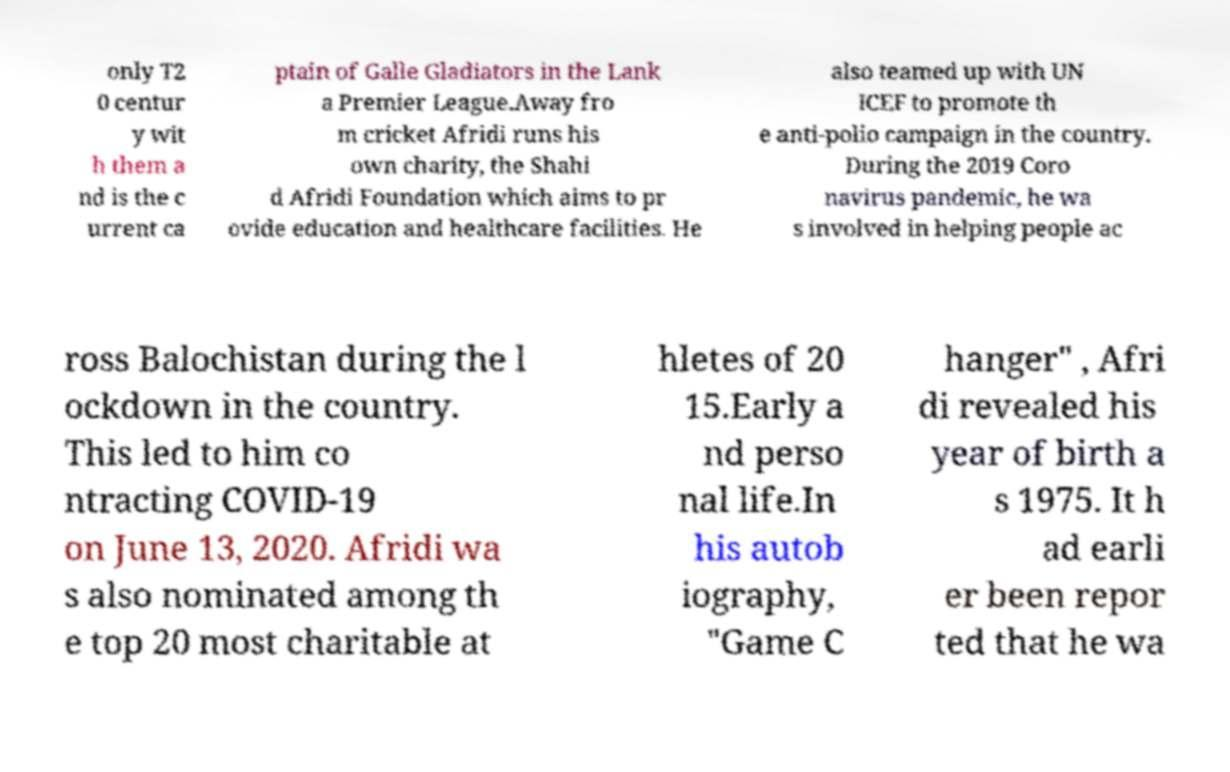Could you assist in decoding the text presented in this image and type it out clearly? only T2 0 centur y wit h them a nd is the c urrent ca ptain of Galle Gladiators in the Lank a Premier League.Away fro m cricket Afridi runs his own charity, the Shahi d Afridi Foundation which aims to pr ovide education and healthcare facilities. He also teamed up with UN ICEF to promote th e anti-polio campaign in the country. During the 2019 Coro navirus pandemic, he wa s involved in helping people ac ross Balochistan during the l ockdown in the country. This led to him co ntracting COVID-19 on June 13, 2020. Afridi wa s also nominated among th e top 20 most charitable at hletes of 20 15.Early a nd perso nal life.In his autob iography, "Game C hanger" , Afri di revealed his year of birth a s 1975. It h ad earli er been repor ted that he wa 